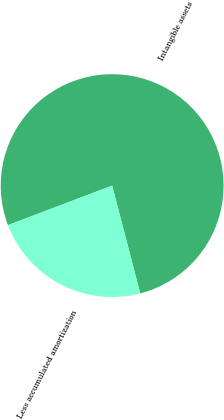<chart> <loc_0><loc_0><loc_500><loc_500><pie_chart><fcel>Intangible assets<fcel>Less accumulated amortization<nl><fcel>76.71%<fcel>23.29%<nl></chart> 